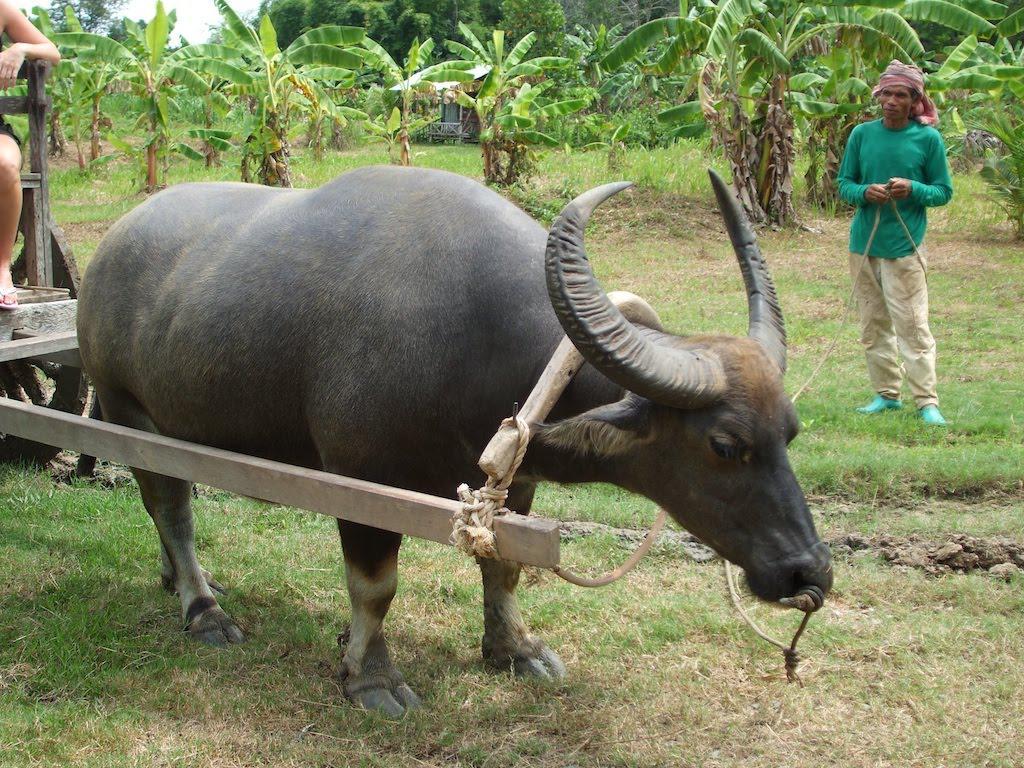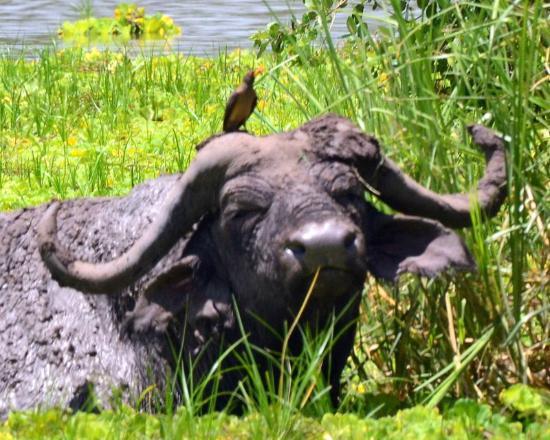The first image is the image on the left, the second image is the image on the right. Given the left and right images, does the statement "there are 2 bulls" hold true? Answer yes or no. Yes. 